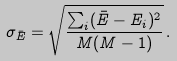<formula> <loc_0><loc_0><loc_500><loc_500>\sigma _ { \bar { E } } = \sqrt { \frac { \sum _ { i } ( \bar { E } - E _ { i } ) ^ { 2 } } { M ( M - 1 ) } } \, .</formula> 